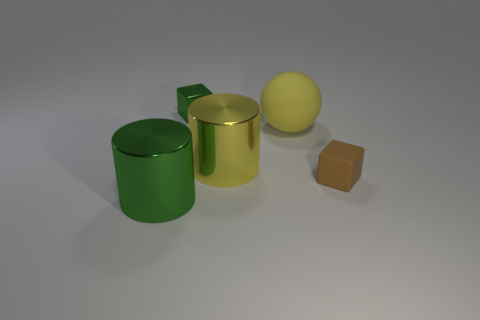Is there any other thing that has the same material as the large green cylinder?
Your response must be concise. Yes. What is the size of the other brown thing that is the same shape as the tiny shiny object?
Provide a short and direct response. Small. Are there more metal cubes right of the small green metallic thing than small green cubes?
Offer a terse response. No. Is the material of the tiny object behind the yellow rubber thing the same as the yellow ball?
Provide a short and direct response. No. There is a yellow thing behind the metallic thing on the right side of the thing that is behind the yellow sphere; how big is it?
Give a very brief answer. Large. What size is the green cylinder that is made of the same material as the tiny green block?
Your response must be concise. Large. The large object that is both on the right side of the tiny metal cube and in front of the large yellow rubber thing is what color?
Provide a short and direct response. Yellow. There is a rubber thing in front of the yellow sphere; does it have the same shape as the yellow object to the left of the yellow ball?
Offer a very short reply. No. There is a green thing that is in front of the shiny block; what is it made of?
Make the answer very short. Metal. There is a metallic object that is the same color as the metal cube; what is its size?
Your answer should be compact. Large. 